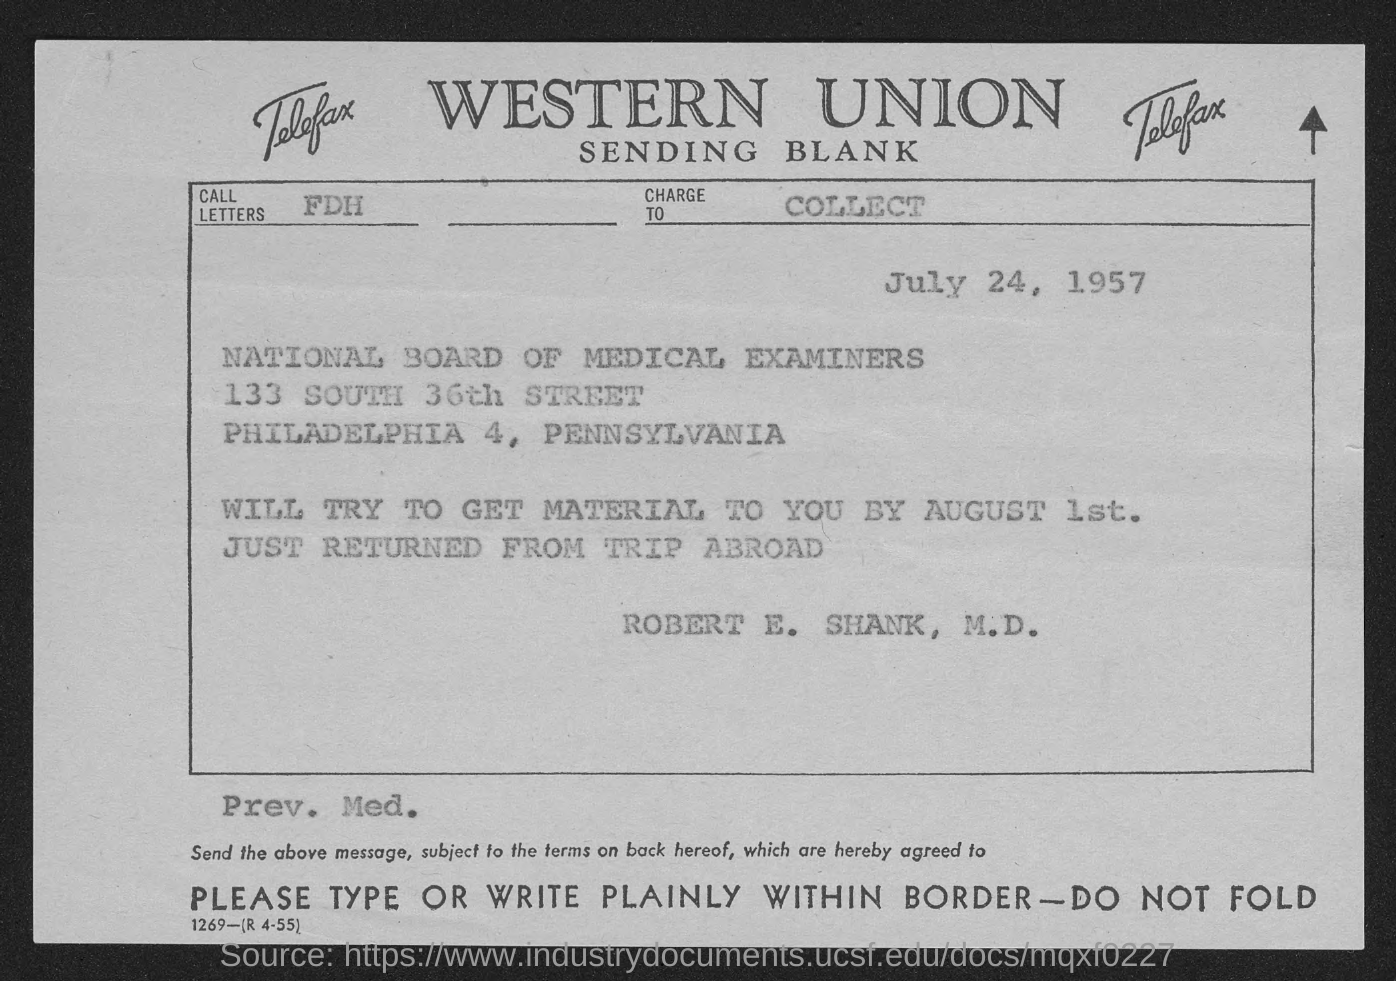Highlight a few significant elements in this photo. The National Board of Medical Examiners is mentioned. The fax is from ROBERT E. SHANK, M.D. The material will be sent by August 1st. The document is dated July 24, 1957. Western Union is the firm that is mentioned at the top of the page. 